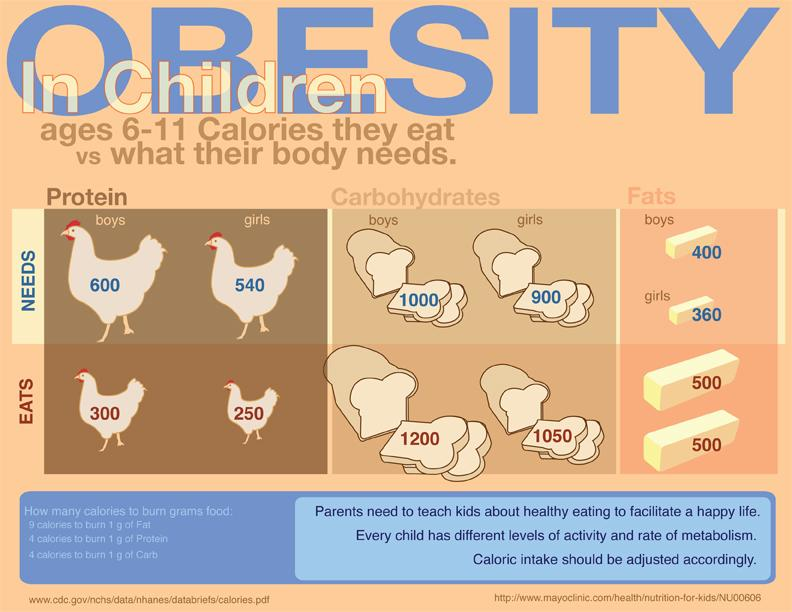Outline some significant characteristics in this image. The difference in the amount of protein consumed by boys and girls is 50 calories. Fats are the nutrient that are consumed in the same amount by both boys and girls. It is recommended that girls consume approximately 540 calories per day to meet their protein needs. The number of sources listed at the bottom is two. The difference between the amount of carbohydrates needed and those actually consumed by boys during a 200-calorie diet is an important factor to consider. 